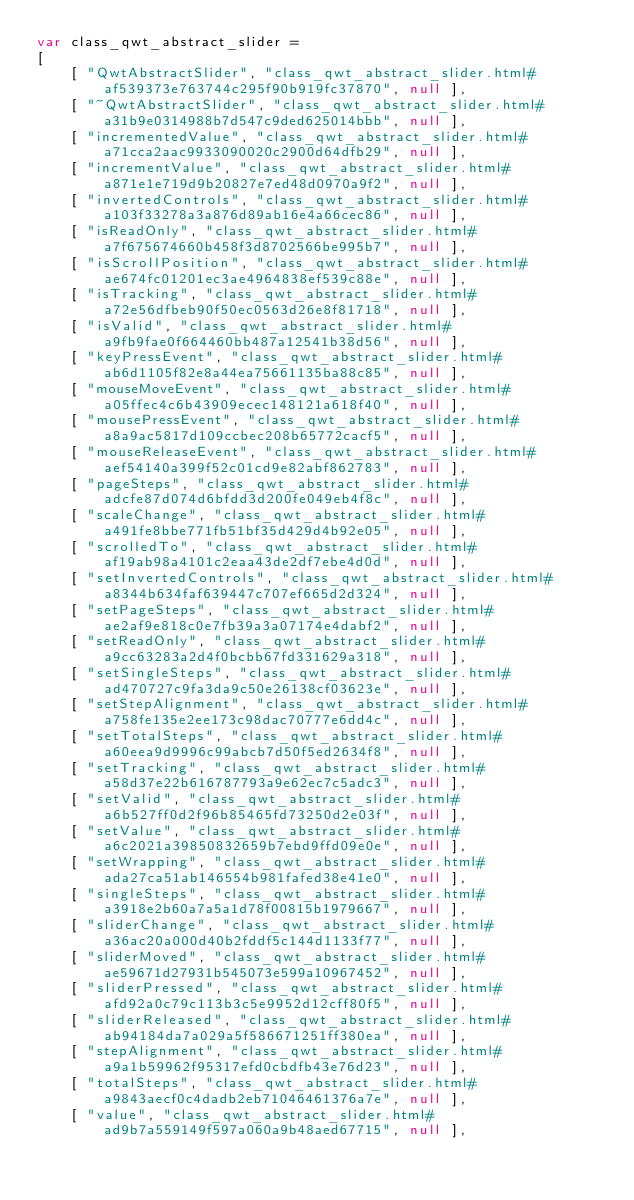<code> <loc_0><loc_0><loc_500><loc_500><_JavaScript_>var class_qwt_abstract_slider =
[
    [ "QwtAbstractSlider", "class_qwt_abstract_slider.html#af539373e763744c295f90b919fc37870", null ],
    [ "~QwtAbstractSlider", "class_qwt_abstract_slider.html#a31b9e0314988b7d547c9ded625014bbb", null ],
    [ "incrementedValue", "class_qwt_abstract_slider.html#a71cca2aac9933090020c2900d64dfb29", null ],
    [ "incrementValue", "class_qwt_abstract_slider.html#a871e1e719d9b20827e7ed48d0970a9f2", null ],
    [ "invertedControls", "class_qwt_abstract_slider.html#a103f33278a3a876d89ab16e4a66cec86", null ],
    [ "isReadOnly", "class_qwt_abstract_slider.html#a7f675674660b458f3d8702566be995b7", null ],
    [ "isScrollPosition", "class_qwt_abstract_slider.html#ae674fc01201ec3ae4964838ef539c88e", null ],
    [ "isTracking", "class_qwt_abstract_slider.html#a72e56dfbeb90f50ec0563d26e8f81718", null ],
    [ "isValid", "class_qwt_abstract_slider.html#a9fb9fae0f664460bb487a12541b38d56", null ],
    [ "keyPressEvent", "class_qwt_abstract_slider.html#ab6d1105f82e8a44ea75661135ba88c85", null ],
    [ "mouseMoveEvent", "class_qwt_abstract_slider.html#a05ffec4c6b43909ecec148121a618f40", null ],
    [ "mousePressEvent", "class_qwt_abstract_slider.html#a8a9ac5817d109ccbec208b65772cacf5", null ],
    [ "mouseReleaseEvent", "class_qwt_abstract_slider.html#aef54140a399f52c01cd9e82abf862783", null ],
    [ "pageSteps", "class_qwt_abstract_slider.html#adcfe87d074d6bfdd3d200fe049eb4f8c", null ],
    [ "scaleChange", "class_qwt_abstract_slider.html#a491fe8bbe771fb51bf35d429d4b92e05", null ],
    [ "scrolledTo", "class_qwt_abstract_slider.html#af19ab98a4101c2eaa43de2df7ebe4d0d", null ],
    [ "setInvertedControls", "class_qwt_abstract_slider.html#a8344b634faf639447c707ef665d2d324", null ],
    [ "setPageSteps", "class_qwt_abstract_slider.html#ae2af9e818c0e7fb39a3a07174e4dabf2", null ],
    [ "setReadOnly", "class_qwt_abstract_slider.html#a9cc63283a2d4f0bcbb67fd331629a318", null ],
    [ "setSingleSteps", "class_qwt_abstract_slider.html#ad470727c9fa3da9c50e26138cf03623e", null ],
    [ "setStepAlignment", "class_qwt_abstract_slider.html#a758fe135e2ee173c98dac70777e6dd4c", null ],
    [ "setTotalSteps", "class_qwt_abstract_slider.html#a60eea9d9996c99abcb7d50f5ed2634f8", null ],
    [ "setTracking", "class_qwt_abstract_slider.html#a58d37e22b616787793a9e62ec7c5adc3", null ],
    [ "setValid", "class_qwt_abstract_slider.html#a6b527ff0d2f96b85465fd73250d2e03f", null ],
    [ "setValue", "class_qwt_abstract_slider.html#a6c2021a39850832659b7ebd9ffd09e0e", null ],
    [ "setWrapping", "class_qwt_abstract_slider.html#ada27ca51ab146554b981fafed38e41e0", null ],
    [ "singleSteps", "class_qwt_abstract_slider.html#a3918e2b60a7a5a1d78f00815b1979667", null ],
    [ "sliderChange", "class_qwt_abstract_slider.html#a36ac20a000d40b2fddf5c144d1133f77", null ],
    [ "sliderMoved", "class_qwt_abstract_slider.html#ae59671d27931b545073e599a10967452", null ],
    [ "sliderPressed", "class_qwt_abstract_slider.html#afd92a0c79c113b3c5e9952d12cff80f5", null ],
    [ "sliderReleased", "class_qwt_abstract_slider.html#ab94184da7a029a5f586671251ff380ea", null ],
    [ "stepAlignment", "class_qwt_abstract_slider.html#a9a1b59962f95317efd0cbdfb43e76d23", null ],
    [ "totalSteps", "class_qwt_abstract_slider.html#a9843aecf0c4dadb2eb71046461376a7e", null ],
    [ "value", "class_qwt_abstract_slider.html#ad9b7a559149f597a060a9b48aed67715", null ],</code> 